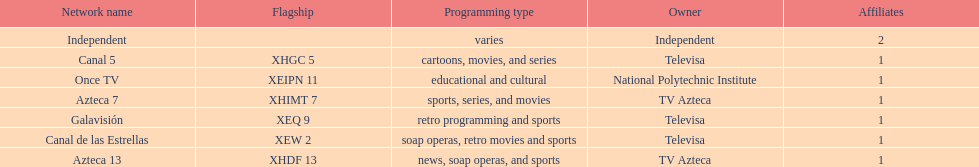Name a station that shows sports but is not televisa. Azteca 7. 